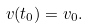<formula> <loc_0><loc_0><loc_500><loc_500>v ( t _ { 0 } ) = v _ { 0 } .</formula> 